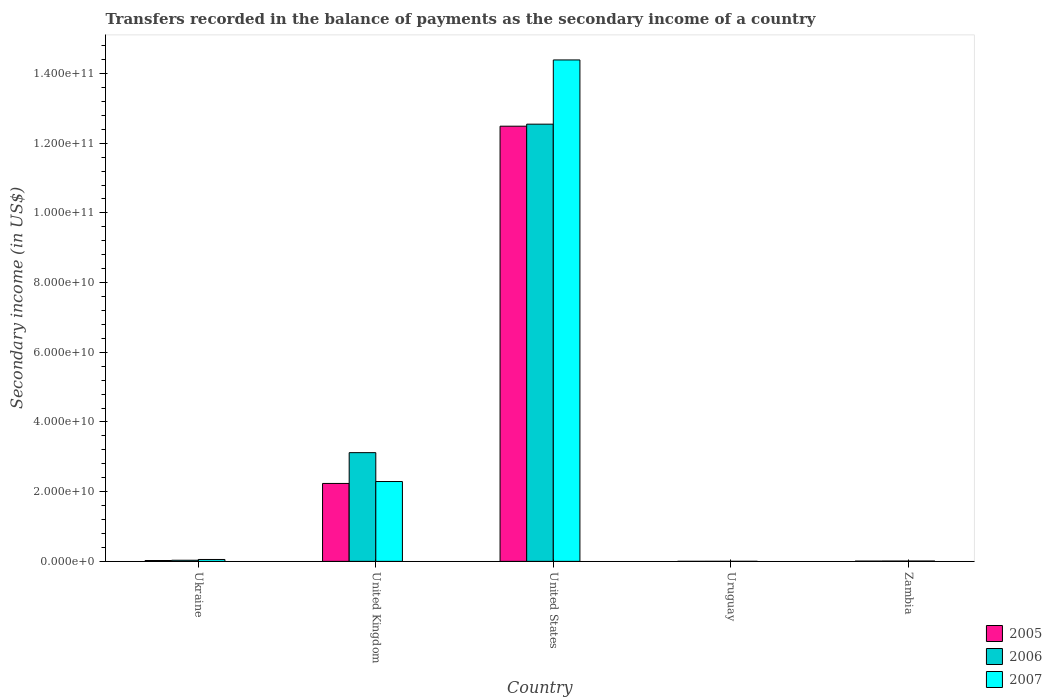How many groups of bars are there?
Offer a very short reply. 5. Are the number of bars per tick equal to the number of legend labels?
Make the answer very short. Yes. Are the number of bars on each tick of the X-axis equal?
Offer a very short reply. Yes. How many bars are there on the 1st tick from the left?
Make the answer very short. 3. How many bars are there on the 4th tick from the right?
Offer a very short reply. 3. What is the label of the 4th group of bars from the left?
Ensure brevity in your answer.  Uruguay. What is the secondary income of in 2007 in Zambia?
Your answer should be very brief. 9.59e+07. Across all countries, what is the maximum secondary income of in 2005?
Keep it short and to the point. 1.25e+11. Across all countries, what is the minimum secondary income of in 2006?
Offer a terse response. 1.10e+07. In which country was the secondary income of in 2006 minimum?
Make the answer very short. Uruguay. What is the total secondary income of in 2006 in the graph?
Ensure brevity in your answer.  1.57e+11. What is the difference between the secondary income of in 2005 in United States and that in Zambia?
Make the answer very short. 1.25e+11. What is the difference between the secondary income of in 2007 in Zambia and the secondary income of in 2005 in Uruguay?
Keep it short and to the point. 8.98e+07. What is the average secondary income of in 2006 per country?
Your answer should be compact. 3.14e+1. What is the difference between the secondary income of of/in 2005 and secondary income of of/in 2007 in Zambia?
Your answer should be very brief. -1.89e+07. What is the ratio of the secondary income of in 2007 in United Kingdom to that in United States?
Provide a short and direct response. 0.16. Is the difference between the secondary income of in 2005 in Ukraine and United States greater than the difference between the secondary income of in 2007 in Ukraine and United States?
Offer a very short reply. Yes. What is the difference between the highest and the second highest secondary income of in 2006?
Your response must be concise. 1.25e+11. What is the difference between the highest and the lowest secondary income of in 2007?
Ensure brevity in your answer.  1.44e+11. Is the sum of the secondary income of in 2006 in Uruguay and Zambia greater than the maximum secondary income of in 2005 across all countries?
Provide a succinct answer. No. What does the 2nd bar from the right in United Kingdom represents?
Offer a very short reply. 2006. How many bars are there?
Offer a very short reply. 15. Where does the legend appear in the graph?
Your response must be concise. Bottom right. How many legend labels are there?
Your answer should be very brief. 3. How are the legend labels stacked?
Your answer should be very brief. Vertical. What is the title of the graph?
Ensure brevity in your answer.  Transfers recorded in the balance of payments as the secondary income of a country. Does "1997" appear as one of the legend labels in the graph?
Ensure brevity in your answer.  No. What is the label or title of the Y-axis?
Give a very brief answer. Secondary income (in US$). What is the Secondary income (in US$) of 2005 in Ukraine?
Provide a succinct answer. 2.39e+08. What is the Secondary income (in US$) in 2006 in Ukraine?
Provide a short and direct response. 3.24e+08. What is the Secondary income (in US$) in 2007 in Ukraine?
Make the answer very short. 5.42e+08. What is the Secondary income (in US$) of 2005 in United Kingdom?
Make the answer very short. 2.24e+1. What is the Secondary income (in US$) of 2006 in United Kingdom?
Make the answer very short. 3.12e+1. What is the Secondary income (in US$) of 2007 in United Kingdom?
Provide a succinct answer. 2.29e+1. What is the Secondary income (in US$) of 2005 in United States?
Ensure brevity in your answer.  1.25e+11. What is the Secondary income (in US$) of 2006 in United States?
Provide a short and direct response. 1.25e+11. What is the Secondary income (in US$) of 2007 in United States?
Your response must be concise. 1.44e+11. What is the Secondary income (in US$) in 2005 in Uruguay?
Ensure brevity in your answer.  6.11e+06. What is the Secondary income (in US$) of 2006 in Uruguay?
Ensure brevity in your answer.  1.10e+07. What is the Secondary income (in US$) in 2007 in Uruguay?
Your response must be concise. 1.37e+07. What is the Secondary income (in US$) in 2005 in Zambia?
Provide a short and direct response. 7.70e+07. What is the Secondary income (in US$) of 2006 in Zambia?
Your response must be concise. 9.27e+07. What is the Secondary income (in US$) in 2007 in Zambia?
Provide a succinct answer. 9.59e+07. Across all countries, what is the maximum Secondary income (in US$) of 2005?
Offer a very short reply. 1.25e+11. Across all countries, what is the maximum Secondary income (in US$) in 2006?
Offer a terse response. 1.25e+11. Across all countries, what is the maximum Secondary income (in US$) of 2007?
Your answer should be compact. 1.44e+11. Across all countries, what is the minimum Secondary income (in US$) of 2005?
Provide a succinct answer. 6.11e+06. Across all countries, what is the minimum Secondary income (in US$) in 2006?
Keep it short and to the point. 1.10e+07. Across all countries, what is the minimum Secondary income (in US$) of 2007?
Your response must be concise. 1.37e+07. What is the total Secondary income (in US$) of 2005 in the graph?
Your response must be concise. 1.48e+11. What is the total Secondary income (in US$) of 2006 in the graph?
Offer a terse response. 1.57e+11. What is the total Secondary income (in US$) of 2007 in the graph?
Your response must be concise. 1.67e+11. What is the difference between the Secondary income (in US$) in 2005 in Ukraine and that in United Kingdom?
Your answer should be compact. -2.21e+1. What is the difference between the Secondary income (in US$) of 2006 in Ukraine and that in United Kingdom?
Make the answer very short. -3.09e+1. What is the difference between the Secondary income (in US$) of 2007 in Ukraine and that in United Kingdom?
Offer a terse response. -2.24e+1. What is the difference between the Secondary income (in US$) in 2005 in Ukraine and that in United States?
Your answer should be compact. -1.25e+11. What is the difference between the Secondary income (in US$) of 2006 in Ukraine and that in United States?
Offer a terse response. -1.25e+11. What is the difference between the Secondary income (in US$) in 2007 in Ukraine and that in United States?
Provide a succinct answer. -1.43e+11. What is the difference between the Secondary income (in US$) of 2005 in Ukraine and that in Uruguay?
Offer a terse response. 2.33e+08. What is the difference between the Secondary income (in US$) in 2006 in Ukraine and that in Uruguay?
Provide a succinct answer. 3.13e+08. What is the difference between the Secondary income (in US$) in 2007 in Ukraine and that in Uruguay?
Ensure brevity in your answer.  5.28e+08. What is the difference between the Secondary income (in US$) of 2005 in Ukraine and that in Zambia?
Your response must be concise. 1.62e+08. What is the difference between the Secondary income (in US$) in 2006 in Ukraine and that in Zambia?
Give a very brief answer. 2.31e+08. What is the difference between the Secondary income (in US$) of 2007 in Ukraine and that in Zambia?
Ensure brevity in your answer.  4.46e+08. What is the difference between the Secondary income (in US$) in 2005 in United Kingdom and that in United States?
Give a very brief answer. -1.03e+11. What is the difference between the Secondary income (in US$) of 2006 in United Kingdom and that in United States?
Provide a succinct answer. -9.43e+1. What is the difference between the Secondary income (in US$) in 2007 in United Kingdom and that in United States?
Your answer should be compact. -1.21e+11. What is the difference between the Secondary income (in US$) in 2005 in United Kingdom and that in Uruguay?
Give a very brief answer. 2.24e+1. What is the difference between the Secondary income (in US$) in 2006 in United Kingdom and that in Uruguay?
Keep it short and to the point. 3.12e+1. What is the difference between the Secondary income (in US$) of 2007 in United Kingdom and that in Uruguay?
Offer a terse response. 2.29e+1. What is the difference between the Secondary income (in US$) of 2005 in United Kingdom and that in Zambia?
Offer a terse response. 2.23e+1. What is the difference between the Secondary income (in US$) of 2006 in United Kingdom and that in Zambia?
Give a very brief answer. 3.11e+1. What is the difference between the Secondary income (in US$) of 2007 in United Kingdom and that in Zambia?
Keep it short and to the point. 2.28e+1. What is the difference between the Secondary income (in US$) in 2005 in United States and that in Uruguay?
Provide a succinct answer. 1.25e+11. What is the difference between the Secondary income (in US$) of 2006 in United States and that in Uruguay?
Ensure brevity in your answer.  1.25e+11. What is the difference between the Secondary income (in US$) in 2007 in United States and that in Uruguay?
Your response must be concise. 1.44e+11. What is the difference between the Secondary income (in US$) of 2005 in United States and that in Zambia?
Give a very brief answer. 1.25e+11. What is the difference between the Secondary income (in US$) of 2006 in United States and that in Zambia?
Your response must be concise. 1.25e+11. What is the difference between the Secondary income (in US$) of 2007 in United States and that in Zambia?
Your answer should be very brief. 1.44e+11. What is the difference between the Secondary income (in US$) of 2005 in Uruguay and that in Zambia?
Offer a terse response. -7.09e+07. What is the difference between the Secondary income (in US$) of 2006 in Uruguay and that in Zambia?
Offer a terse response. -8.17e+07. What is the difference between the Secondary income (in US$) of 2007 in Uruguay and that in Zambia?
Keep it short and to the point. -8.22e+07. What is the difference between the Secondary income (in US$) of 2005 in Ukraine and the Secondary income (in US$) of 2006 in United Kingdom?
Give a very brief answer. -3.10e+1. What is the difference between the Secondary income (in US$) of 2005 in Ukraine and the Secondary income (in US$) of 2007 in United Kingdom?
Keep it short and to the point. -2.27e+1. What is the difference between the Secondary income (in US$) in 2006 in Ukraine and the Secondary income (in US$) in 2007 in United Kingdom?
Your response must be concise. -2.26e+1. What is the difference between the Secondary income (in US$) in 2005 in Ukraine and the Secondary income (in US$) in 2006 in United States?
Make the answer very short. -1.25e+11. What is the difference between the Secondary income (in US$) of 2005 in Ukraine and the Secondary income (in US$) of 2007 in United States?
Provide a short and direct response. -1.44e+11. What is the difference between the Secondary income (in US$) in 2006 in Ukraine and the Secondary income (in US$) in 2007 in United States?
Your answer should be compact. -1.44e+11. What is the difference between the Secondary income (in US$) of 2005 in Ukraine and the Secondary income (in US$) of 2006 in Uruguay?
Provide a short and direct response. 2.28e+08. What is the difference between the Secondary income (in US$) of 2005 in Ukraine and the Secondary income (in US$) of 2007 in Uruguay?
Your response must be concise. 2.25e+08. What is the difference between the Secondary income (in US$) of 2006 in Ukraine and the Secondary income (in US$) of 2007 in Uruguay?
Provide a succinct answer. 3.10e+08. What is the difference between the Secondary income (in US$) of 2005 in Ukraine and the Secondary income (in US$) of 2006 in Zambia?
Your answer should be very brief. 1.46e+08. What is the difference between the Secondary income (in US$) in 2005 in Ukraine and the Secondary income (in US$) in 2007 in Zambia?
Ensure brevity in your answer.  1.43e+08. What is the difference between the Secondary income (in US$) of 2006 in Ukraine and the Secondary income (in US$) of 2007 in Zambia?
Your answer should be compact. 2.28e+08. What is the difference between the Secondary income (in US$) of 2005 in United Kingdom and the Secondary income (in US$) of 2006 in United States?
Your answer should be very brief. -1.03e+11. What is the difference between the Secondary income (in US$) in 2005 in United Kingdom and the Secondary income (in US$) in 2007 in United States?
Your answer should be compact. -1.22e+11. What is the difference between the Secondary income (in US$) of 2006 in United Kingdom and the Secondary income (in US$) of 2007 in United States?
Your answer should be compact. -1.13e+11. What is the difference between the Secondary income (in US$) in 2005 in United Kingdom and the Secondary income (in US$) in 2006 in Uruguay?
Your response must be concise. 2.24e+1. What is the difference between the Secondary income (in US$) of 2005 in United Kingdom and the Secondary income (in US$) of 2007 in Uruguay?
Your answer should be very brief. 2.23e+1. What is the difference between the Secondary income (in US$) of 2006 in United Kingdom and the Secondary income (in US$) of 2007 in Uruguay?
Your response must be concise. 3.12e+1. What is the difference between the Secondary income (in US$) in 2005 in United Kingdom and the Secondary income (in US$) in 2006 in Zambia?
Ensure brevity in your answer.  2.23e+1. What is the difference between the Secondary income (in US$) in 2005 in United Kingdom and the Secondary income (in US$) in 2007 in Zambia?
Offer a terse response. 2.23e+1. What is the difference between the Secondary income (in US$) in 2006 in United Kingdom and the Secondary income (in US$) in 2007 in Zambia?
Your answer should be compact. 3.11e+1. What is the difference between the Secondary income (in US$) in 2005 in United States and the Secondary income (in US$) in 2006 in Uruguay?
Provide a short and direct response. 1.25e+11. What is the difference between the Secondary income (in US$) in 2005 in United States and the Secondary income (in US$) in 2007 in Uruguay?
Provide a succinct answer. 1.25e+11. What is the difference between the Secondary income (in US$) in 2006 in United States and the Secondary income (in US$) in 2007 in Uruguay?
Make the answer very short. 1.25e+11. What is the difference between the Secondary income (in US$) of 2005 in United States and the Secondary income (in US$) of 2006 in Zambia?
Your answer should be very brief. 1.25e+11. What is the difference between the Secondary income (in US$) of 2005 in United States and the Secondary income (in US$) of 2007 in Zambia?
Your answer should be very brief. 1.25e+11. What is the difference between the Secondary income (in US$) in 2006 in United States and the Secondary income (in US$) in 2007 in Zambia?
Offer a terse response. 1.25e+11. What is the difference between the Secondary income (in US$) of 2005 in Uruguay and the Secondary income (in US$) of 2006 in Zambia?
Keep it short and to the point. -8.66e+07. What is the difference between the Secondary income (in US$) in 2005 in Uruguay and the Secondary income (in US$) in 2007 in Zambia?
Provide a succinct answer. -8.98e+07. What is the difference between the Secondary income (in US$) in 2006 in Uruguay and the Secondary income (in US$) in 2007 in Zambia?
Ensure brevity in your answer.  -8.49e+07. What is the average Secondary income (in US$) in 2005 per country?
Offer a very short reply. 2.95e+1. What is the average Secondary income (in US$) of 2006 per country?
Make the answer very short. 3.14e+1. What is the average Secondary income (in US$) in 2007 per country?
Offer a terse response. 3.35e+1. What is the difference between the Secondary income (in US$) in 2005 and Secondary income (in US$) in 2006 in Ukraine?
Keep it short and to the point. -8.50e+07. What is the difference between the Secondary income (in US$) in 2005 and Secondary income (in US$) in 2007 in Ukraine?
Keep it short and to the point. -3.03e+08. What is the difference between the Secondary income (in US$) of 2006 and Secondary income (in US$) of 2007 in Ukraine?
Offer a terse response. -2.18e+08. What is the difference between the Secondary income (in US$) of 2005 and Secondary income (in US$) of 2006 in United Kingdom?
Make the answer very short. -8.84e+09. What is the difference between the Secondary income (in US$) in 2005 and Secondary income (in US$) in 2007 in United Kingdom?
Provide a succinct answer. -5.48e+08. What is the difference between the Secondary income (in US$) of 2006 and Secondary income (in US$) of 2007 in United Kingdom?
Make the answer very short. 8.29e+09. What is the difference between the Secondary income (in US$) in 2005 and Secondary income (in US$) in 2006 in United States?
Give a very brief answer. -5.83e+08. What is the difference between the Secondary income (in US$) in 2005 and Secondary income (in US$) in 2007 in United States?
Offer a terse response. -1.90e+1. What is the difference between the Secondary income (in US$) of 2006 and Secondary income (in US$) of 2007 in United States?
Ensure brevity in your answer.  -1.84e+1. What is the difference between the Secondary income (in US$) of 2005 and Secondary income (in US$) of 2006 in Uruguay?
Provide a short and direct response. -4.93e+06. What is the difference between the Secondary income (in US$) of 2005 and Secondary income (in US$) of 2007 in Uruguay?
Your answer should be very brief. -7.60e+06. What is the difference between the Secondary income (in US$) in 2006 and Secondary income (in US$) in 2007 in Uruguay?
Ensure brevity in your answer.  -2.67e+06. What is the difference between the Secondary income (in US$) in 2005 and Secondary income (in US$) in 2006 in Zambia?
Give a very brief answer. -1.58e+07. What is the difference between the Secondary income (in US$) in 2005 and Secondary income (in US$) in 2007 in Zambia?
Offer a very short reply. -1.89e+07. What is the difference between the Secondary income (in US$) of 2006 and Secondary income (in US$) of 2007 in Zambia?
Offer a terse response. -3.16e+06. What is the ratio of the Secondary income (in US$) in 2005 in Ukraine to that in United Kingdom?
Give a very brief answer. 0.01. What is the ratio of the Secondary income (in US$) in 2006 in Ukraine to that in United Kingdom?
Offer a terse response. 0.01. What is the ratio of the Secondary income (in US$) of 2007 in Ukraine to that in United Kingdom?
Give a very brief answer. 0.02. What is the ratio of the Secondary income (in US$) in 2005 in Ukraine to that in United States?
Your answer should be compact. 0. What is the ratio of the Secondary income (in US$) in 2006 in Ukraine to that in United States?
Offer a terse response. 0. What is the ratio of the Secondary income (in US$) in 2007 in Ukraine to that in United States?
Keep it short and to the point. 0. What is the ratio of the Secondary income (in US$) in 2005 in Ukraine to that in Uruguay?
Your answer should be compact. 39.12. What is the ratio of the Secondary income (in US$) in 2006 in Ukraine to that in Uruguay?
Your answer should be compact. 29.34. What is the ratio of the Secondary income (in US$) in 2007 in Ukraine to that in Uruguay?
Provide a succinct answer. 39.53. What is the ratio of the Secondary income (in US$) in 2005 in Ukraine to that in Zambia?
Provide a succinct answer. 3.11. What is the ratio of the Secondary income (in US$) in 2006 in Ukraine to that in Zambia?
Keep it short and to the point. 3.49. What is the ratio of the Secondary income (in US$) in 2007 in Ukraine to that in Zambia?
Give a very brief answer. 5.65. What is the ratio of the Secondary income (in US$) of 2005 in United Kingdom to that in United States?
Your answer should be compact. 0.18. What is the ratio of the Secondary income (in US$) of 2006 in United Kingdom to that in United States?
Ensure brevity in your answer.  0.25. What is the ratio of the Secondary income (in US$) in 2007 in United Kingdom to that in United States?
Your answer should be compact. 0.16. What is the ratio of the Secondary income (in US$) in 2005 in United Kingdom to that in Uruguay?
Your response must be concise. 3660.45. What is the ratio of the Secondary income (in US$) of 2006 in United Kingdom to that in Uruguay?
Offer a very short reply. 2825.35. What is the ratio of the Secondary income (in US$) of 2007 in United Kingdom to that in Uruguay?
Ensure brevity in your answer.  1670.79. What is the ratio of the Secondary income (in US$) in 2005 in United Kingdom to that in Zambia?
Make the answer very short. 290.55. What is the ratio of the Secondary income (in US$) of 2006 in United Kingdom to that in Zambia?
Keep it short and to the point. 336.44. What is the ratio of the Secondary income (in US$) in 2007 in United Kingdom to that in Zambia?
Keep it short and to the point. 238.89. What is the ratio of the Secondary income (in US$) of 2005 in United States to that in Uruguay?
Your answer should be very brief. 2.04e+04. What is the ratio of the Secondary income (in US$) of 2006 in United States to that in Uruguay?
Ensure brevity in your answer.  1.14e+04. What is the ratio of the Secondary income (in US$) in 2007 in United States to that in Uruguay?
Ensure brevity in your answer.  1.05e+04. What is the ratio of the Secondary income (in US$) of 2005 in United States to that in Zambia?
Provide a short and direct response. 1622.64. What is the ratio of the Secondary income (in US$) of 2006 in United States to that in Zambia?
Make the answer very short. 1352.91. What is the ratio of the Secondary income (in US$) in 2007 in United States to that in Zambia?
Give a very brief answer. 1500.45. What is the ratio of the Secondary income (in US$) in 2005 in Uruguay to that in Zambia?
Your answer should be compact. 0.08. What is the ratio of the Secondary income (in US$) of 2006 in Uruguay to that in Zambia?
Provide a succinct answer. 0.12. What is the ratio of the Secondary income (in US$) of 2007 in Uruguay to that in Zambia?
Provide a short and direct response. 0.14. What is the difference between the highest and the second highest Secondary income (in US$) of 2005?
Provide a succinct answer. 1.03e+11. What is the difference between the highest and the second highest Secondary income (in US$) in 2006?
Keep it short and to the point. 9.43e+1. What is the difference between the highest and the second highest Secondary income (in US$) of 2007?
Make the answer very short. 1.21e+11. What is the difference between the highest and the lowest Secondary income (in US$) of 2005?
Keep it short and to the point. 1.25e+11. What is the difference between the highest and the lowest Secondary income (in US$) in 2006?
Ensure brevity in your answer.  1.25e+11. What is the difference between the highest and the lowest Secondary income (in US$) of 2007?
Your answer should be very brief. 1.44e+11. 